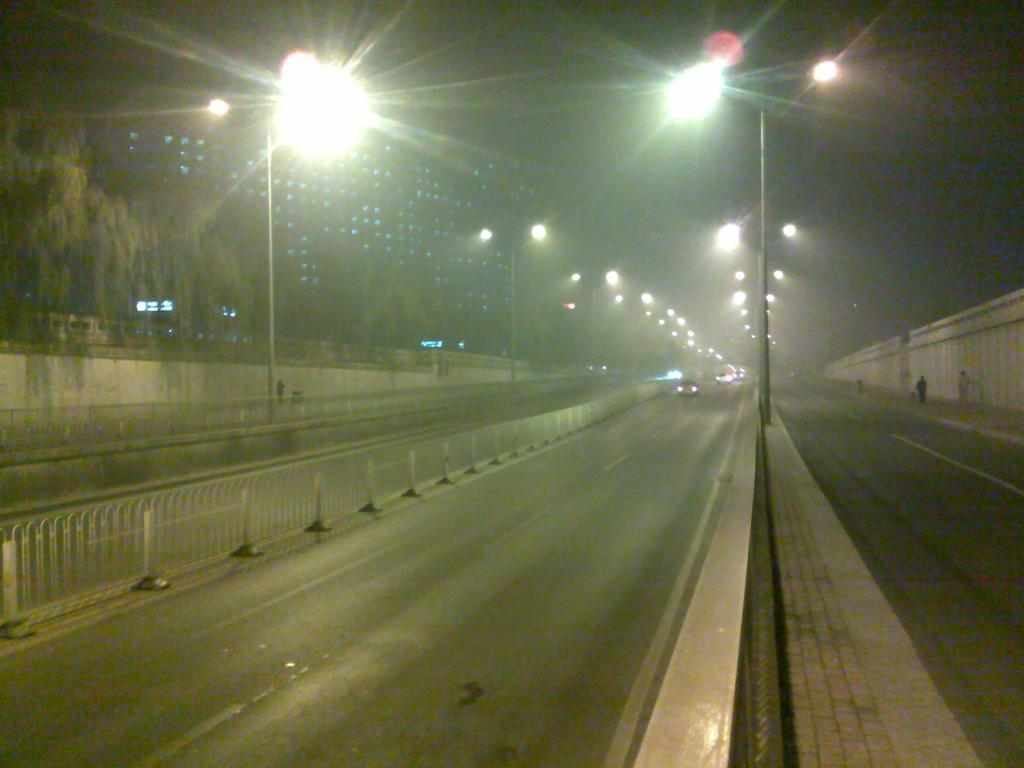What type of infrastructure can be seen in the image? There are roads in the image. What feature is present alongside the roads? There are lights on the sides of the road. What safety feature is visible in the image? There are railings in the image. What type of structure can be seen in the image? There is a wall in the image. What natural elements are present in the image? There are trees in the image. What type of man-made structure is visible in the background? There is a building in the background of the image. What type of soap is being used to clean the railings in the image? There is no soap or cleaning activity present in the image; it only shows roads, lights, railings, a wall, trees, and a building in the background. 